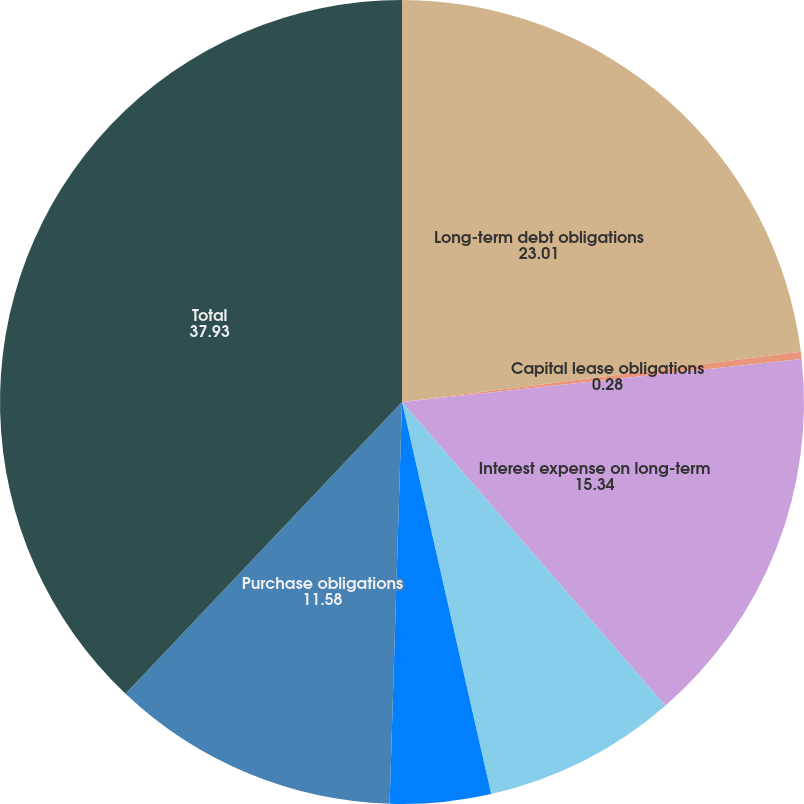<chart> <loc_0><loc_0><loc_500><loc_500><pie_chart><fcel>Long-term debt obligations<fcel>Capital lease obligations<fcel>Interest expense on long-term<fcel>Satellite-related obligations<fcel>Operating lease obligations<fcel>Purchase obligations<fcel>Total<nl><fcel>23.01%<fcel>0.28%<fcel>15.34%<fcel>7.81%<fcel>4.05%<fcel>11.58%<fcel>37.93%<nl></chart> 